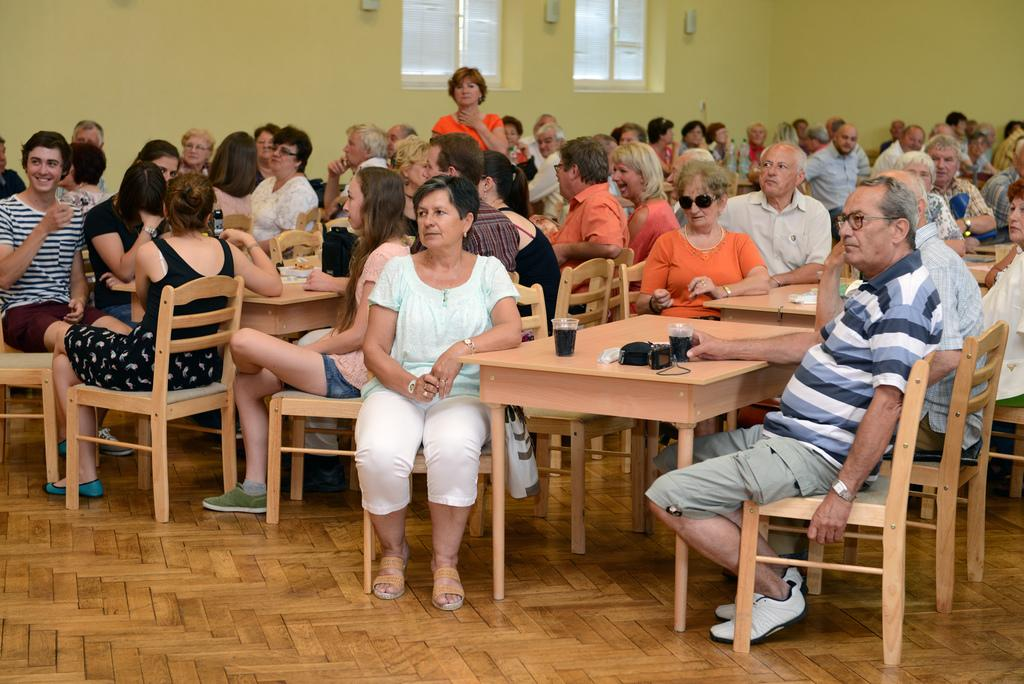How many people are in the image? There is a group of people in the image. What are the people doing in the image? The people are sitting on chairs, drinking, having a conversation, and laughing. What can be seen in the background of the image? There is a glass window in the image. What type of plot is being discussed by the people in the image? There is no indication in the image of a specific plot being discussed; the people are simply having a conversation. Can you hear the thunder in the image? There is no sound in the image, so it is not possible to hear thunder or any other sounds. 